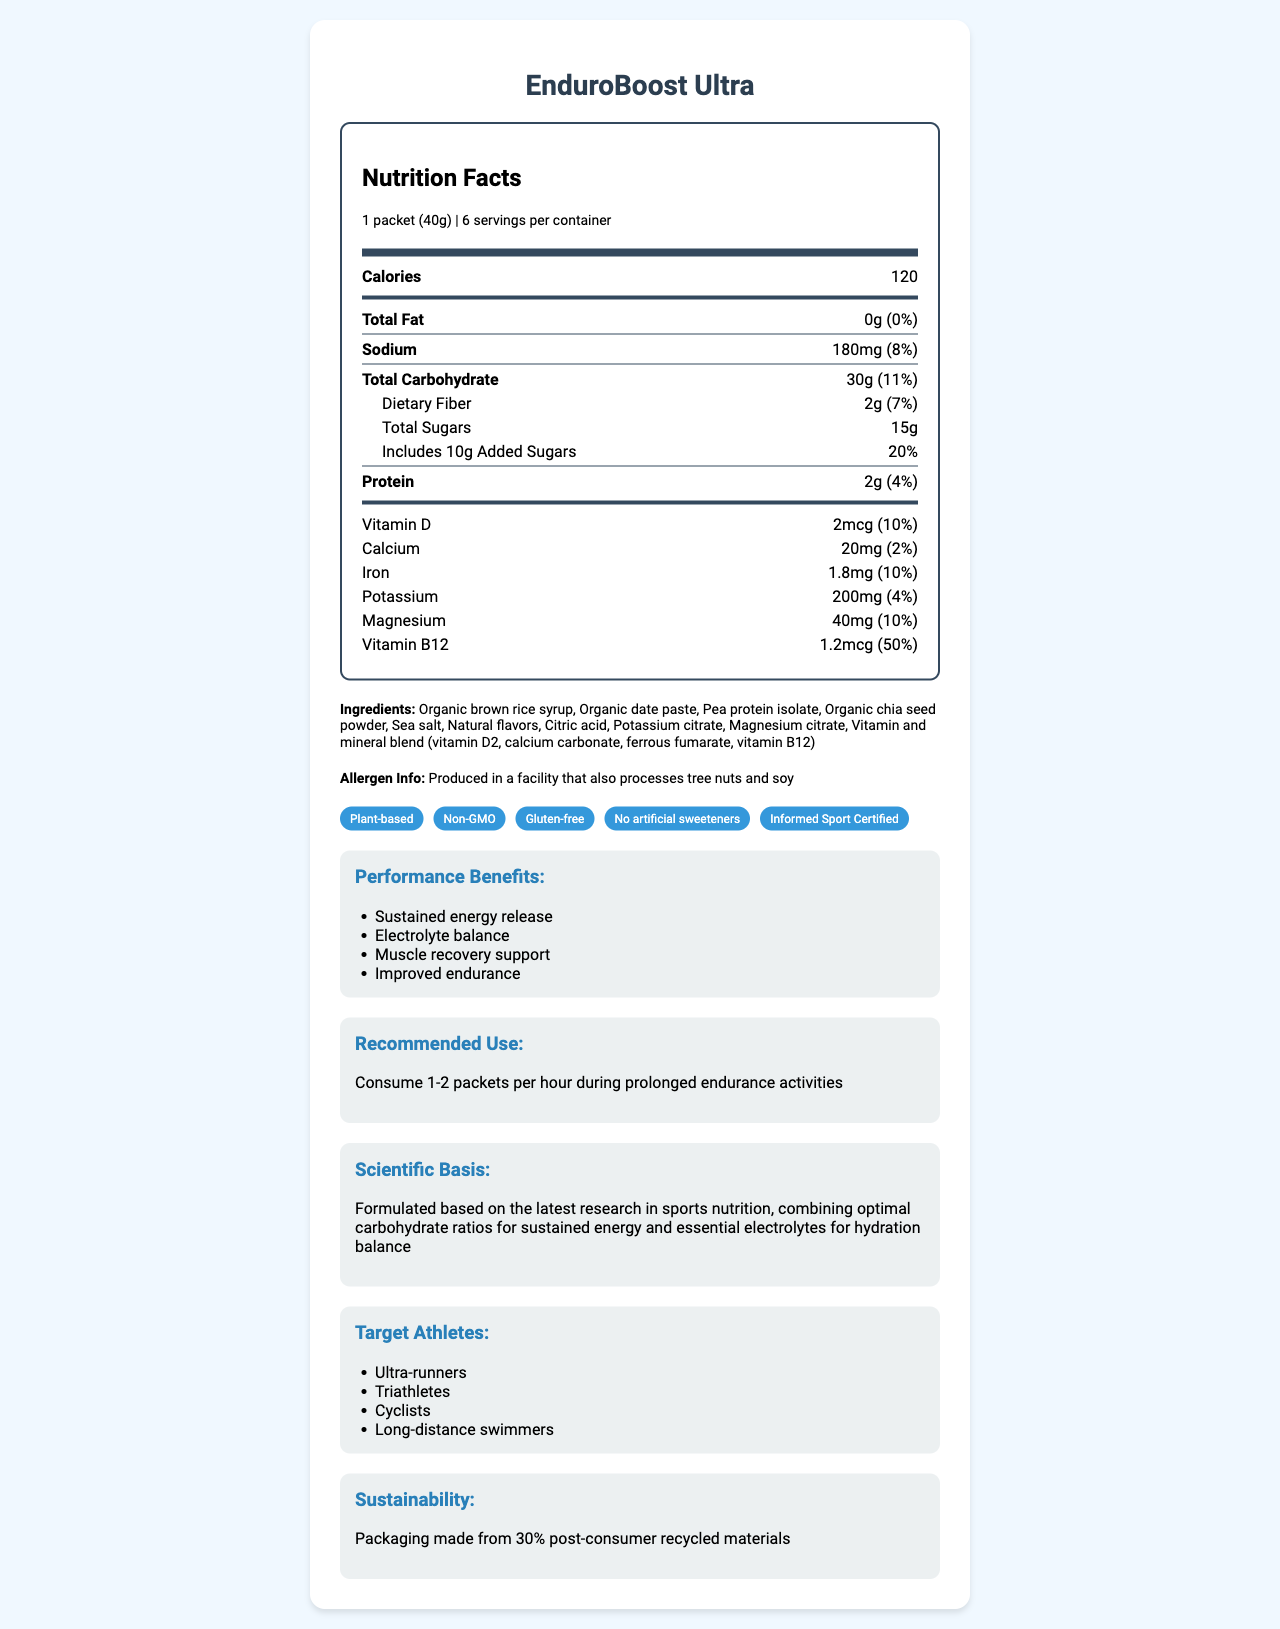what is the serving size? The serving size is clearly stated at the top of the nutrition facts label as "1 packet (40g)".
Answer: 1 packet (40g) How many calories does one serving of EnduroBoost Ultra contain? The calorie count is prominently displayed under the serving size and servings per container information.
Answer: 120 What percentage of the daily value of sodium does one packet provide? This information is located next to the sodium content, which states "180mg (8%)".
Answer: 8% How much dietary fiber is in each serving? The dietary fiber content is listed under the total carbohydrate section: "2g (7%)".
Answer: 2g Which vitamin is present in the highest percentage of daily value? The document shows vitamin B12 at 50% daily value, which is higher than other listed vitamins and minerals.
Answer: Vitamin B12 Does the product contain any fat? The label specifies "Total Fat: 0g (0%)", which means the product does not contain any fat.
Answer: No What are the main ingredients in the EnduroBoost Ultra energy gel? These ingredients are listed at the end of the nutrition label document.
Answer: Organic brown rice syrup, Organic date paste, Pea protein isolate, Organic chia seed powder, Sea salt Which of the following is a claim made by this product? A. Contains caffeine B. Non-GMO C. Dairy-free D. High in protein Among the listed claims, "Non-GMO" is specified in the document, while the others are not.
Answer: B What is the recommended use for this product? A. Consume 1 packet per day B. Consume 1 packet before a workout C. Consume 1-2 packets per hour during prolonged endurance activities The document states the recommended use as "Consume 1-2 packets per hour during prolonged endurance activities".
Answer: C Is this product suitable for athletes with gluten allergies? The claims section includes "Gluten-free", indicating suitability for those with gluten allergies.
Answer: Yes Summarize the main idea of the document. The document details the nutritional content of EnduroBoost Ultra, including calories, carbs, vitamins, and minerals. It also lists ingredients, claims like "Non-GMO" and "Gluten-free", and benefits such as sustained energy and electrolyte balance. Recommended use for endurance athletes and packaging sustainability are also discussed.
Answer: The document provides the nutrition facts, ingredients, claims, and usage recommendations for EnduroBoost Ultra, a plant-based energy gel designed for endurance athletes. It highlights key nutrients, performance benefits, and sustainability efforts. What is the total carbohydrate content per serving, and how much of it is from sugars? The document states the total carbohydrate content as 30g and total sugars content as 15g.
Answer: Total Carbohydrate: 30g, Total Sugars: 15g List any allergens that might be present due to production conditions. The allergen information states that the product is produced in a facility that also processes tree nuts and soy.
Answer: Tree nuts, Soy What are the intended target athletes for this product? These athlete types are listed under the "Target Athletes" section.
Answer: Ultra-runners, Triathletes, Cyclists, Long-distance swimmers Is there any information regarding the carbohydrate source used in the product? The ingredient list includes "Organic brown rice syrup" and "Organic date paste", which are sources of carbohydrates.
Answer: Yes What is the document's publication date? The document does not provide any information regarding its publication date.
Answer: Cannot be determined 